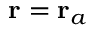<formula> <loc_0><loc_0><loc_500><loc_500>r = r _ { a }</formula> 